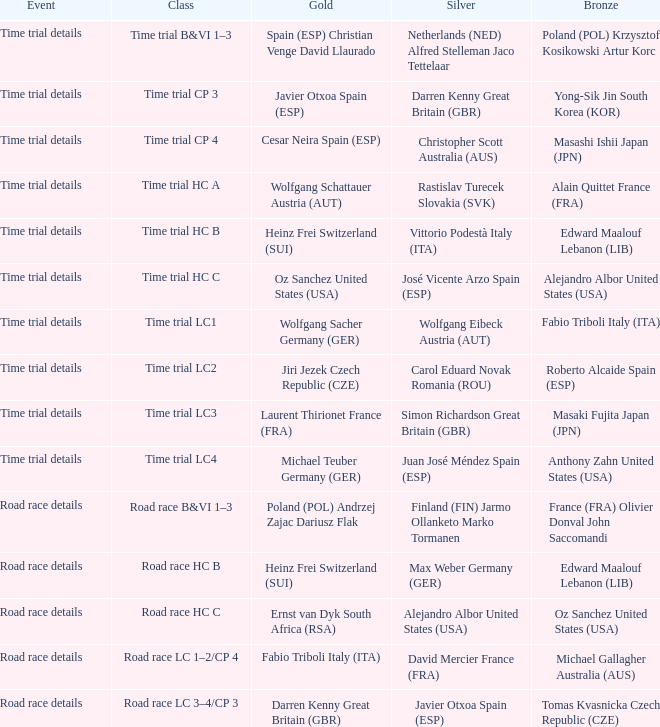Who was awarded gold when silver is wolfgang eibeck austria (aut)? Wolfgang Sacher Germany (GER). 